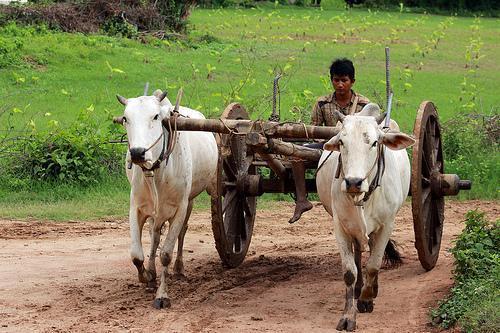How many oxen are there?
Give a very brief answer. 2. 